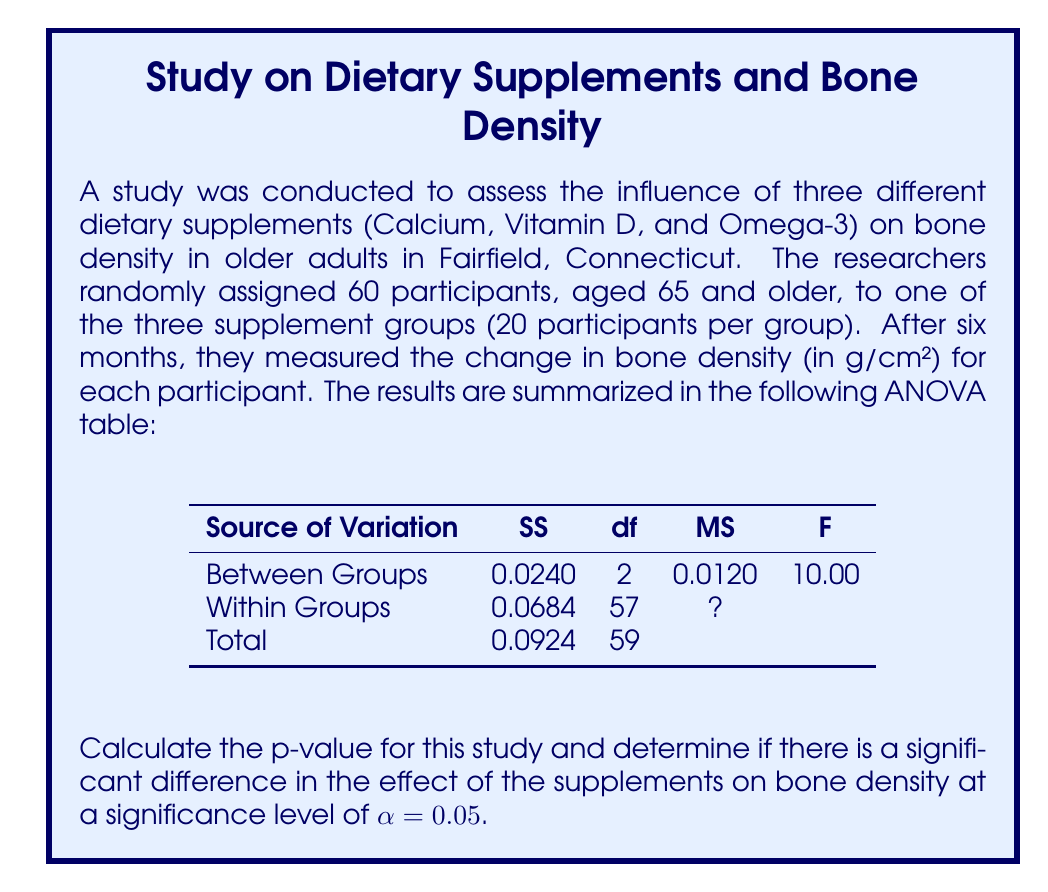Solve this math problem. To solve this problem, we'll follow these steps:

1. Complete the ANOVA table by calculating the missing Within Groups MS.
2. Determine the critical F-value.
3. Calculate the p-value.
4. Compare the p-value to the significance level.

Step 1: Complete the ANOVA table

The Within Groups MS (Mean Square) is calculated by dividing the Within Groups SS by its df:

$$ MS_{Within} = \frac{SS_{Within}}{df_{Within}} = \frac{0.0684}{57} = 0.0012 $$

Step 2: Determine the critical F-value

We need to find the critical F-value with:
- Numerator degrees of freedom = 2
- Denominator degrees of freedom = 57
- α = 0.05

Using an F-distribution table or calculator, we find:

$$ F_{critical} = F_{0.05, 2, 57} \approx 3.16 $$

Step 3: Calculate the p-value

To find the p-value, we need to use the F-distribution with 2 and 57 degrees of freedom. The test statistic F = 10.00 is already given in the ANOVA table.

Using an F-distribution calculator or statistical software, we find:

$$ p\text{-value} = P(F_{2,57} \geq 10.00) \approx 0.0002 $$

Step 4: Compare the p-value to the significance level

The p-value (0.0002) is less than the significance level (α = 0.05).

Therefore, we reject the null hypothesis and conclude that there is a significant difference in the effect of the supplements on bone density.
Answer: The p-value is approximately 0.0002, which is less than the significance level of 0.05. Therefore, there is a significant difference in the effect of the supplements on bone density in older adults. 